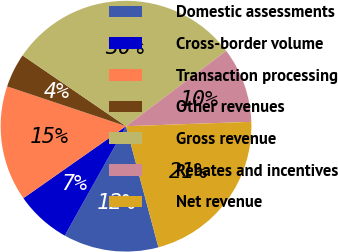Convert chart to OTSL. <chart><loc_0><loc_0><loc_500><loc_500><pie_chart><fcel>Domestic assessments<fcel>Cross-border volume<fcel>Transaction processing<fcel>Other revenues<fcel>Gross revenue<fcel>Rebates and incentives<fcel>Net revenue<nl><fcel>12.29%<fcel>7.14%<fcel>14.87%<fcel>4.41%<fcel>30.19%<fcel>9.71%<fcel>21.39%<nl></chart> 